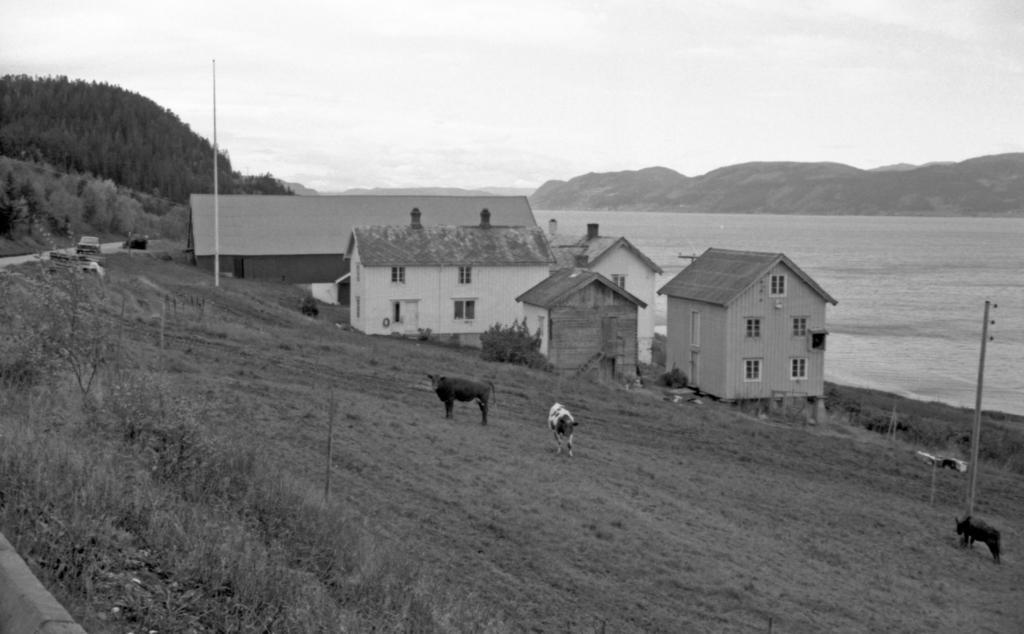In one or two sentences, can you explain what this image depicts? In this picture I can observe animals on the land. In the middle of the picture I can observe houses. On the right side I can observe a river. In the background I can observe hills and sky. 